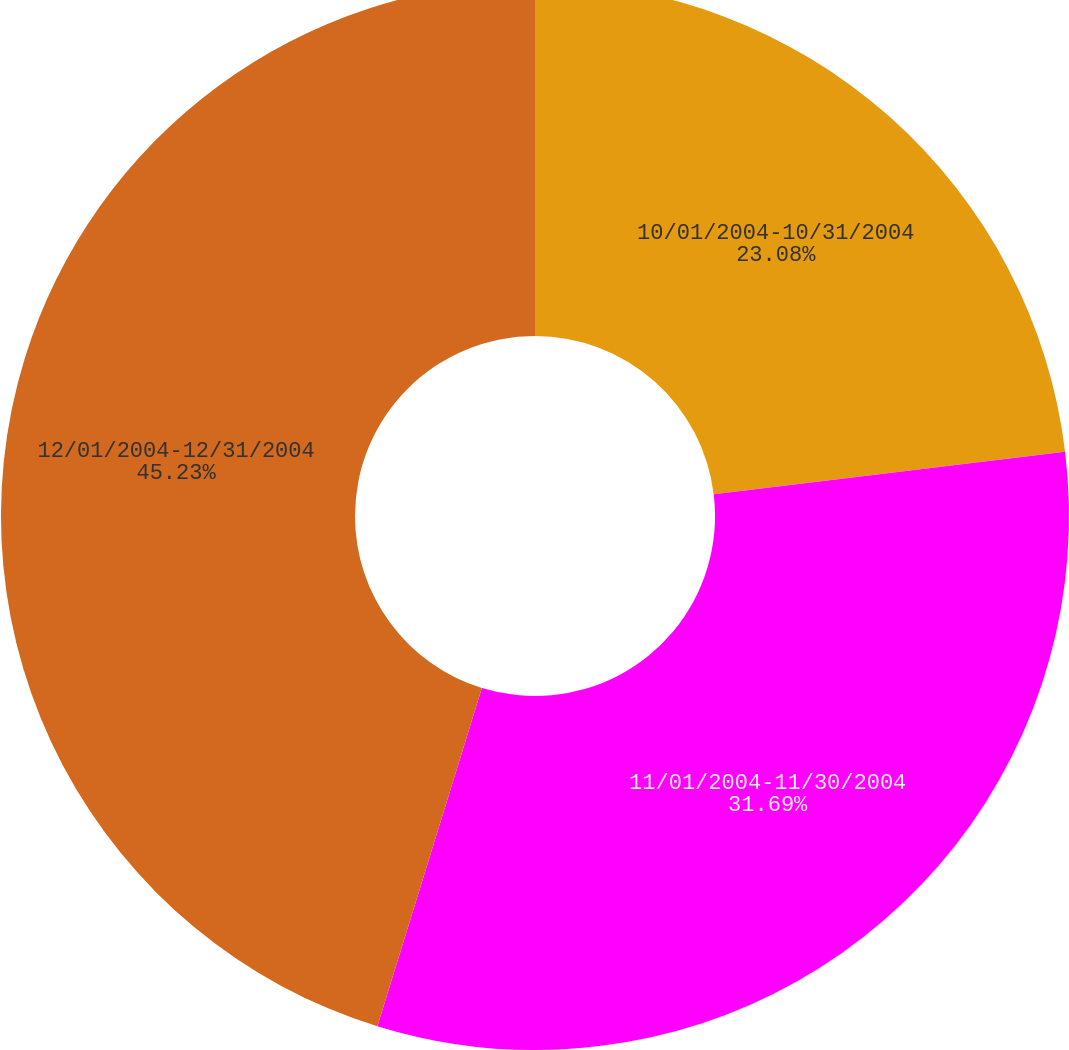Convert chart. <chart><loc_0><loc_0><loc_500><loc_500><pie_chart><fcel>10/01/2004-10/31/2004<fcel>11/01/2004-11/30/2004<fcel>12/01/2004-12/31/2004<nl><fcel>23.08%<fcel>31.69%<fcel>45.23%<nl></chart> 